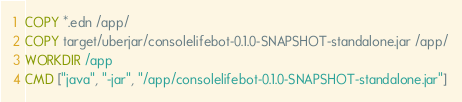<code> <loc_0><loc_0><loc_500><loc_500><_Dockerfile_>COPY *.edn /app/
COPY target/uberjar/consolelifebot-0.1.0-SNAPSHOT-standalone.jar /app/
WORKDIR /app
CMD ["java", "-jar", "/app/consolelifebot-0.1.0-SNAPSHOT-standalone.jar"]

</code> 